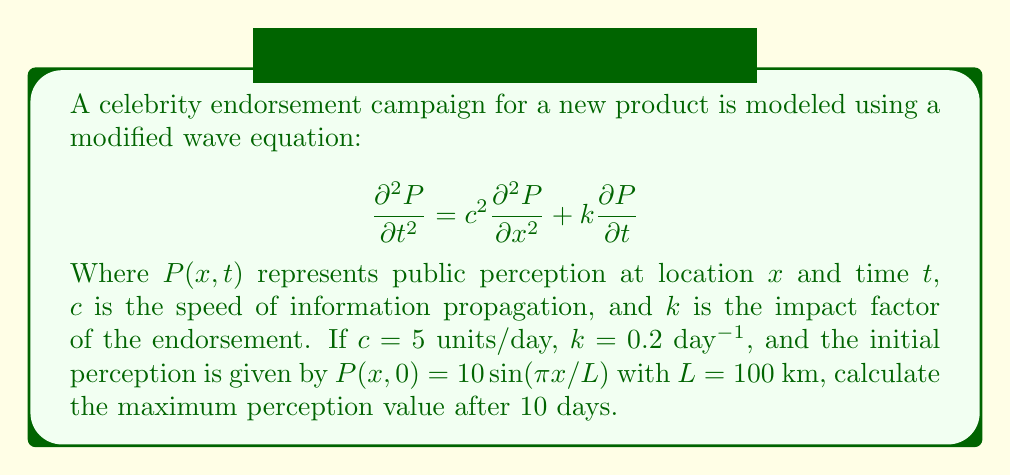Can you answer this question? To solve this problem, we need to follow these steps:

1) The given equation is a damped wave equation. The general solution for such an equation is of the form:

   $$P(x,t) = e^{-kt/2}[A\cos(\omega t) + B\sin(\omega t)]\sin(\pi x/L)$$

   Where $\omega = \sqrt{c^2(\pi/L)^2 - (k/2)^2}$

2) Given:
   $c = 5$ units/day
   $k = 0.2$ day$^{-1}$
   $L = 100$ km
   Initial condition: $P(x,0) = 10\sin(\pi x/L)$

3) Calculate $\omega$:
   $$\omega = \sqrt{5^2(\pi/100)^2 - (0.2/2)^2} \approx 0.1570$$

4) From the initial condition, we can determine that $A = 10$ and $B = 0$.

5) Therefore, our solution becomes:
   $$P(x,t) = 10e^{-0.1t}\cos(0.1570t)\sin(\pi x/L)$$

6) To find the maximum perception value, we need to maximize this function with respect to $x$ and $t$.

7) The $\sin(\pi x/L)$ term is maximized when $x = L/2 = 50$ km, giving a value of 1.

8) At $t = 10$ days, the time-dependent part becomes:
   $$10e^{-0.1(10)}\cos(0.1570(10)) = 10e^{-1}\cos(1.570) \approx 3.679$$

9) Therefore, the maximum perception value after 10 days is approximately 3.679.
Answer: 3.679 